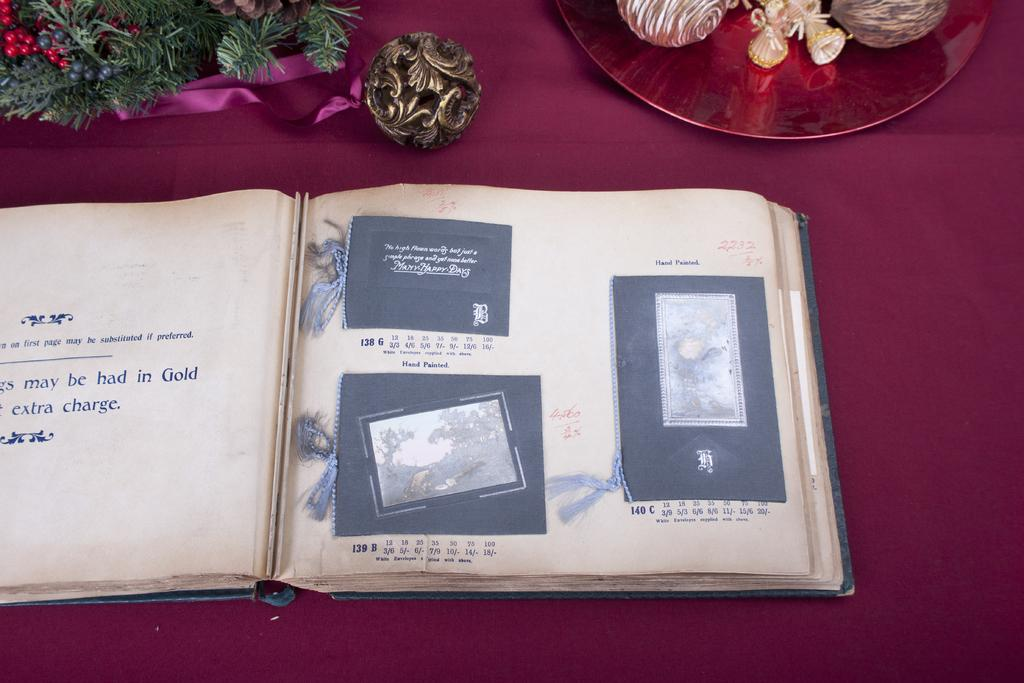<image>
Offer a succinct explanation of the picture presented. A book is open to a page where the left page has the words "extra charge" on it. 